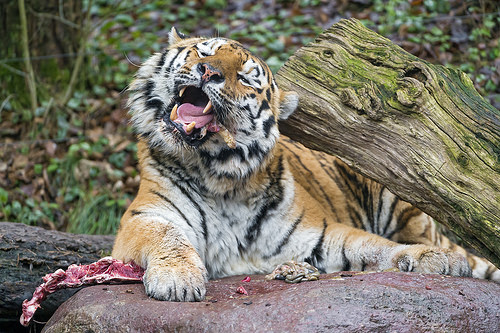<image>
Is there a tiger next to the log? Yes. The tiger is positioned adjacent to the log, located nearby in the same general area. 